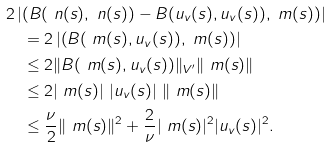Convert formula to latex. <formula><loc_0><loc_0><loc_500><loc_500>& 2 \left | \left ( B ( \ n ( s ) , \ n ( s ) ) - B ( u _ { v } ( s ) , u _ { v } ( s ) ) , \ m ( s ) \right ) \right | \\ & \quad = 2 \left | \left ( B ( \ m ( s ) , u _ { v } ( s ) ) , \ m ( s ) \right ) \right | \\ & \quad \leq 2 \| B ( \ m ( s ) , u _ { v } ( s ) ) \| _ { V ^ { \prime } } \| \ m ( s ) \| \\ & \quad \leq 2 | \ m ( s ) | \ | u _ { v } ( s ) | \ \| \ m ( s ) \| \\ & \quad \leq \frac { \nu } { 2 } \| \ m ( s ) \| ^ { 2 } + \frac { 2 } { \nu } | \ m ( s ) | ^ { 2 } | u _ { v } ( s ) | ^ { 2 } .</formula> 